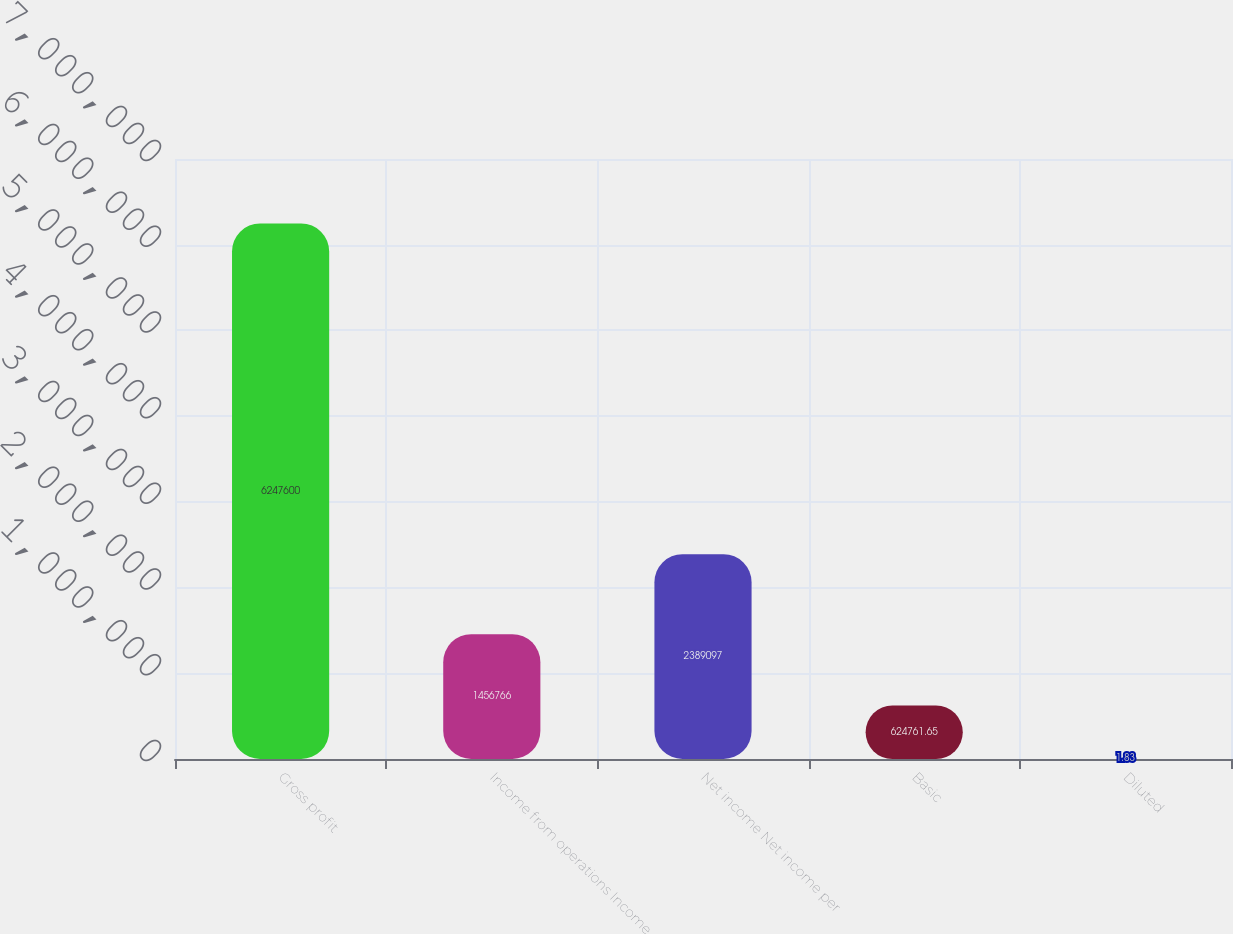Convert chart to OTSL. <chart><loc_0><loc_0><loc_500><loc_500><bar_chart><fcel>Gross profit<fcel>Income from operations Income<fcel>Net income Net income per<fcel>Basic<fcel>Diluted<nl><fcel>6.2476e+06<fcel>1.45677e+06<fcel>2.3891e+06<fcel>624762<fcel>1.83<nl></chart> 